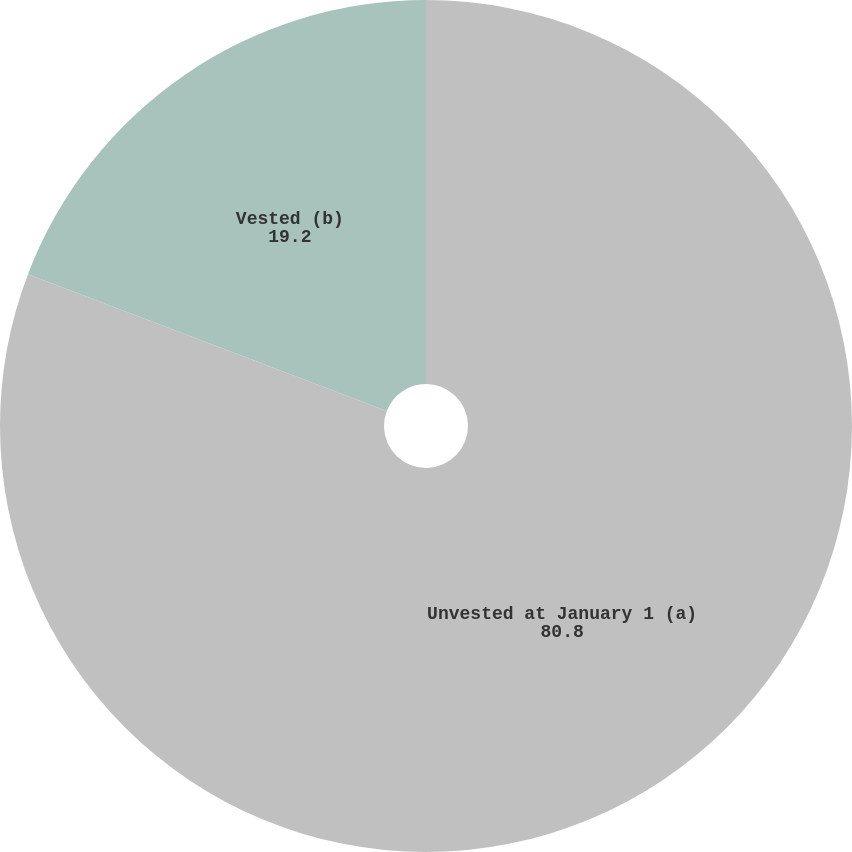Convert chart. <chart><loc_0><loc_0><loc_500><loc_500><pie_chart><fcel>Unvested at January 1 (a)<fcel>Vested (b)<nl><fcel>80.8%<fcel>19.2%<nl></chart> 